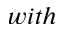<formula> <loc_0><loc_0><loc_500><loc_500>w i t h</formula> 